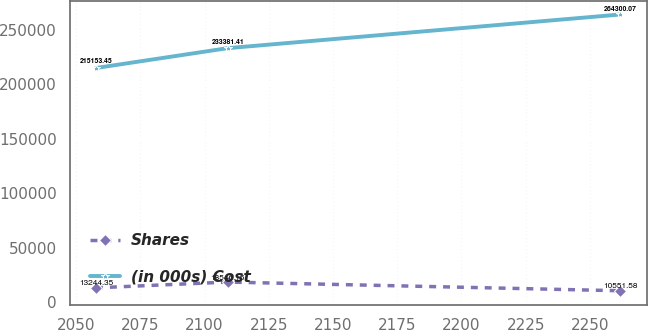<chart> <loc_0><loc_0><loc_500><loc_500><line_chart><ecel><fcel>Shares<fcel>(in 000s) Cost<nl><fcel>2057.74<fcel>13244.4<fcel>215153<nl><fcel>2109.02<fcel>18546.2<fcel>233381<nl><fcel>2261.84<fcel>10551.6<fcel>264300<nl></chart> 